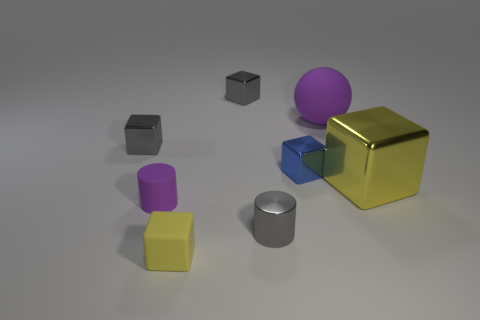The small metallic object in front of the blue cube right of the purple object that is to the left of the blue metallic thing is what color?
Your answer should be very brief. Gray. Is the material of the block that is in front of the big yellow object the same as the blue object?
Keep it short and to the point. No. How many other objects are there of the same material as the blue object?
Provide a short and direct response. 4. There is a ball that is the same size as the yellow metallic object; what material is it?
Your answer should be very brief. Rubber. There is a yellow object that is to the right of the large matte thing; is it the same shape as the shiny thing behind the large purple rubber ball?
Provide a short and direct response. Yes. The purple object that is the same size as the blue thing is what shape?
Make the answer very short. Cylinder. Is the tiny block that is behind the large matte sphere made of the same material as the small object in front of the gray cylinder?
Provide a short and direct response. No. Is there a small yellow matte thing behind the small metal object left of the matte cylinder?
Your answer should be compact. No. What is the color of the small cylinder that is the same material as the tiny yellow object?
Give a very brief answer. Purple. Is the number of small rubber cubes greater than the number of yellow cubes?
Offer a very short reply. No. 